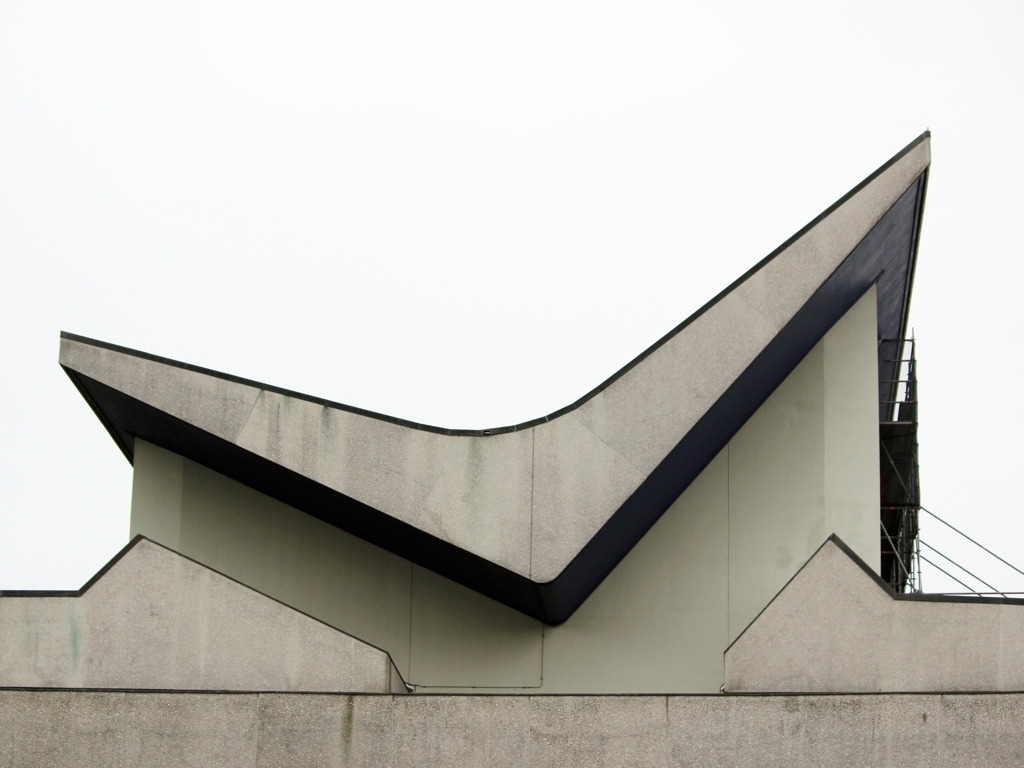Could you describe how the weather might be affecting the mood of this picture? The overcast sky creates a somber and subdued atmosphere, casting a diffused light that softens shadows and contributes to the overall muted tones of the image. 